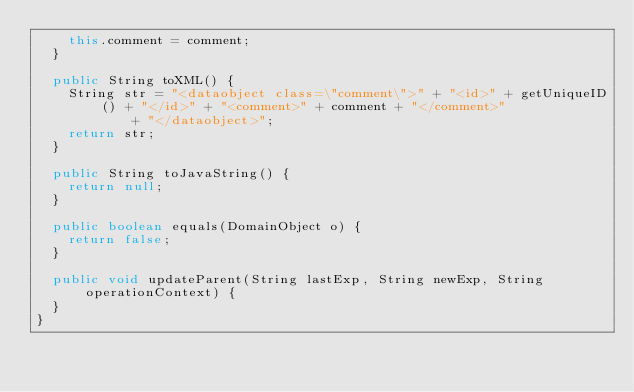<code> <loc_0><loc_0><loc_500><loc_500><_Java_>		this.comment = comment;
	}

	public String toXML() {
		String str = "<dataobject class=\"comment\">" + "<id>" + getUniqueID() + "</id>" + "<comment>" + comment + "</comment>"
		        + "</dataobject>";
		return str;
	}

	public String toJavaString() {
		return null;
	}

	public boolean equals(DomainObject o) {
		return false;
	}

	public void updateParent(String lastExp, String newExp, String operationContext) {
	}
}
</code> 